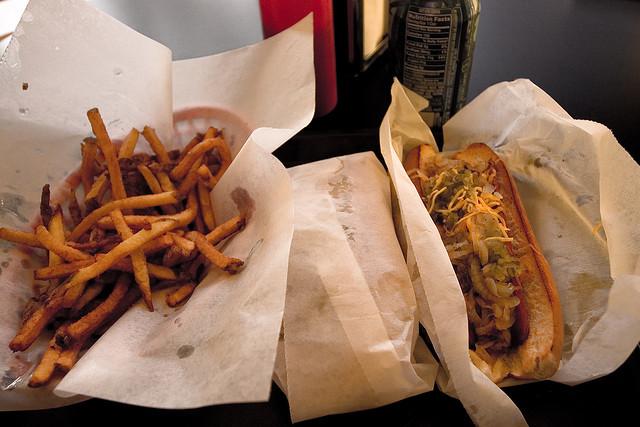What is in the can?
Be succinct. Soda. What is the food wrapped in?
Keep it brief. Paper. Are those French fries?
Answer briefly. Yes. 